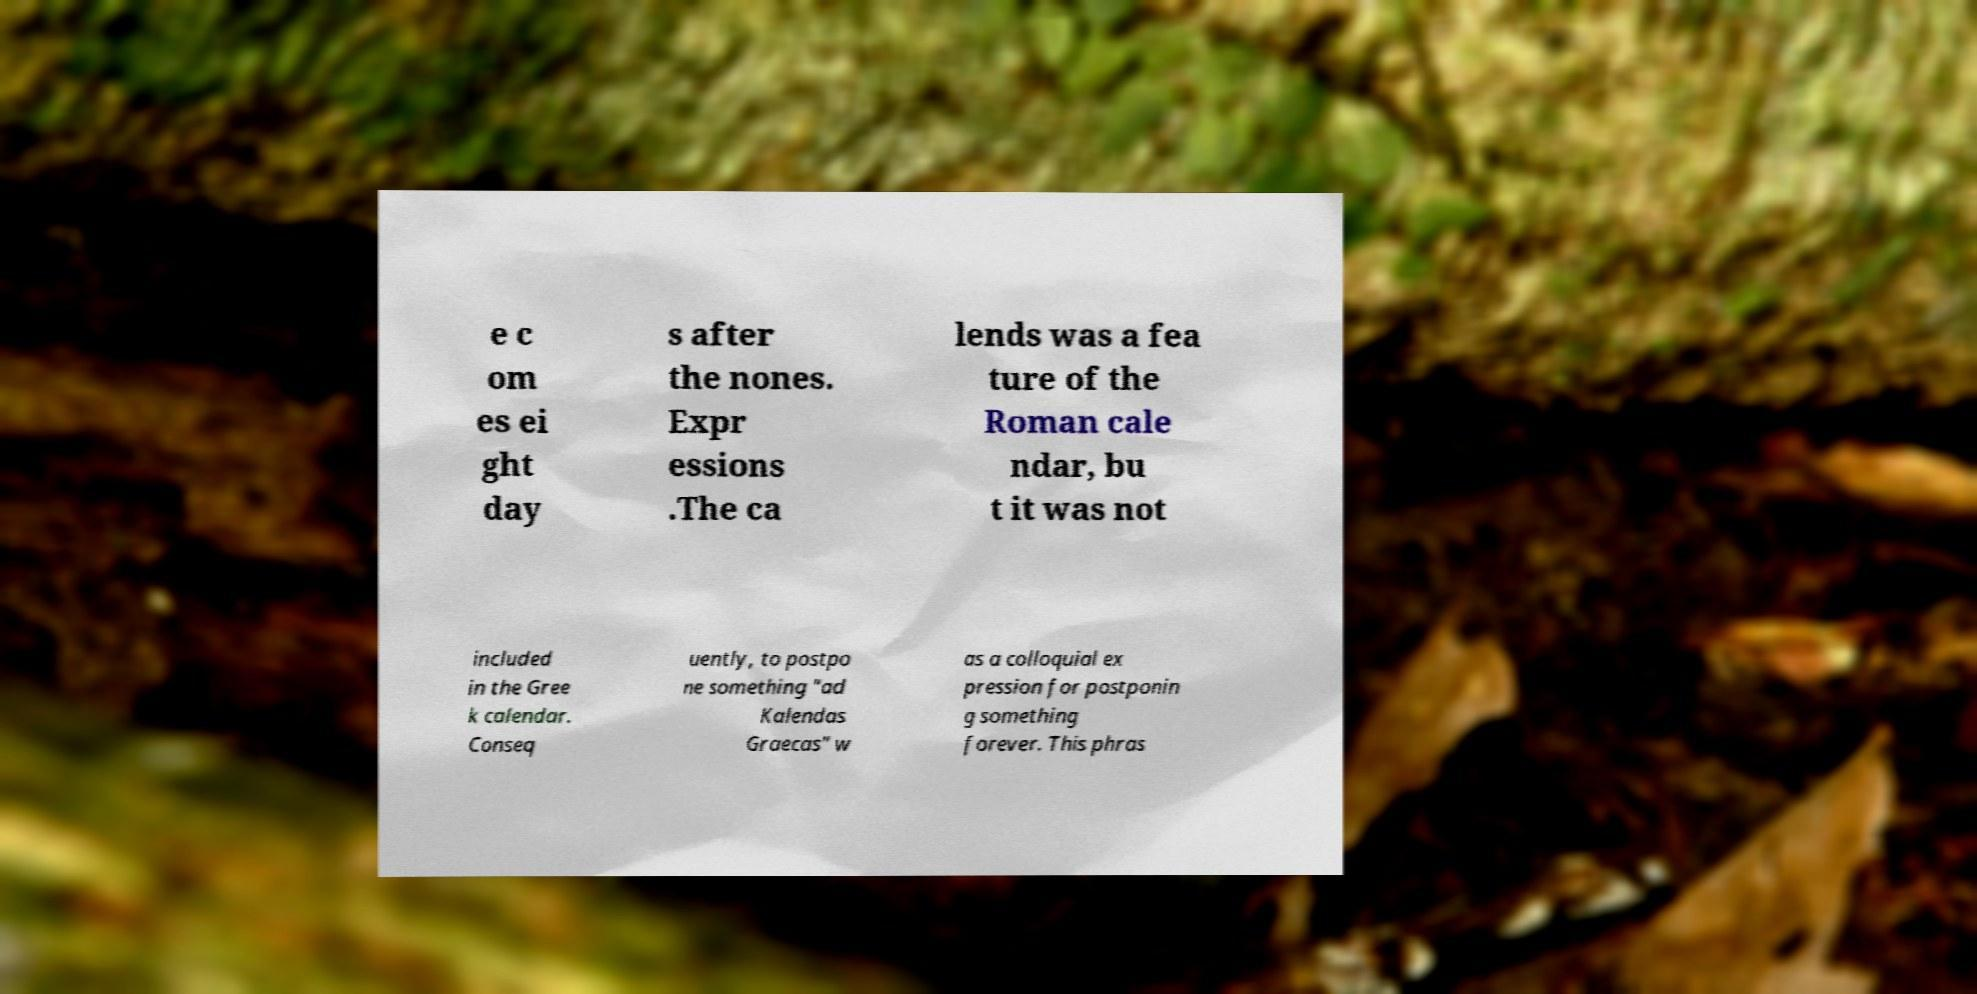Please read and relay the text visible in this image. What does it say? e c om es ei ght day s after the nones. Expr essions .The ca lends was a fea ture of the Roman cale ndar, bu t it was not included in the Gree k calendar. Conseq uently, to postpo ne something "ad Kalendas Graecas" w as a colloquial ex pression for postponin g something forever. This phras 